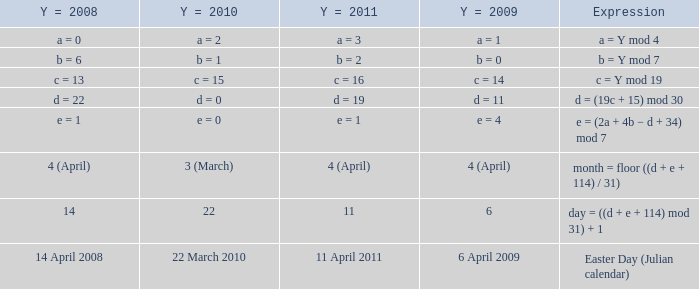What is the y = 2008 when the expression is easter day (julian calendar)? 14 April 2008. 